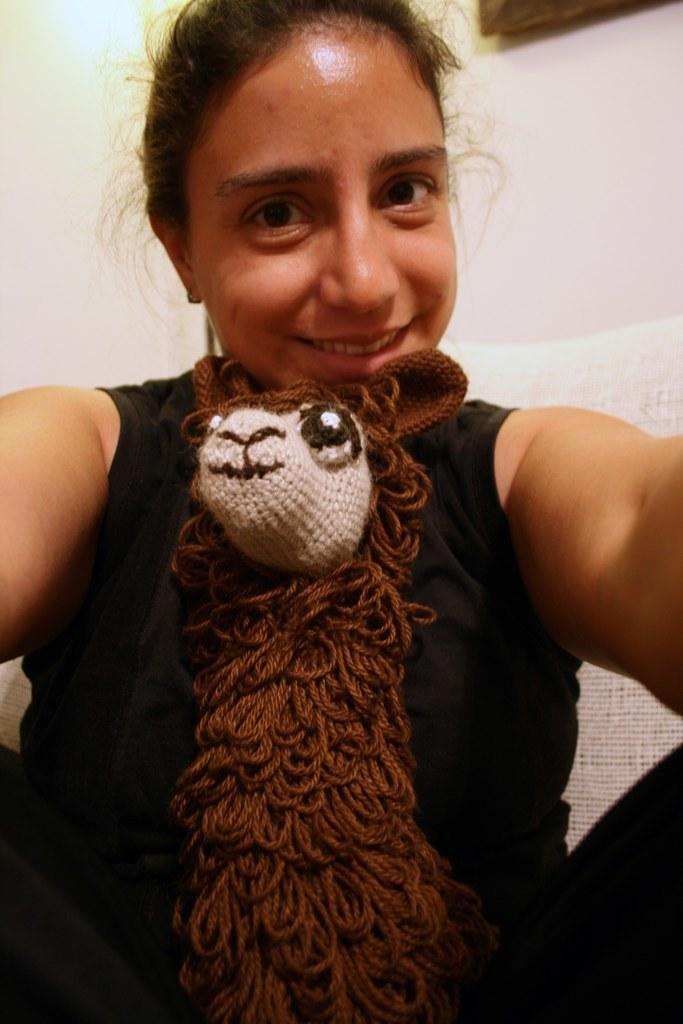What is the woman wearing in the image? There is a woman wearing a dress in the image. What can be seen in the foreground of the image? There is a doll in the foreground of the image. What is present on the wall in the background of the image? There is a photo frame on the wall in the background of the image. What type of argument is the woman having with the army in the image? There is no argument or army present in the image; it only features a woman wearing a dress, a doll in the foreground, and a photo frame on the wall in the background. 